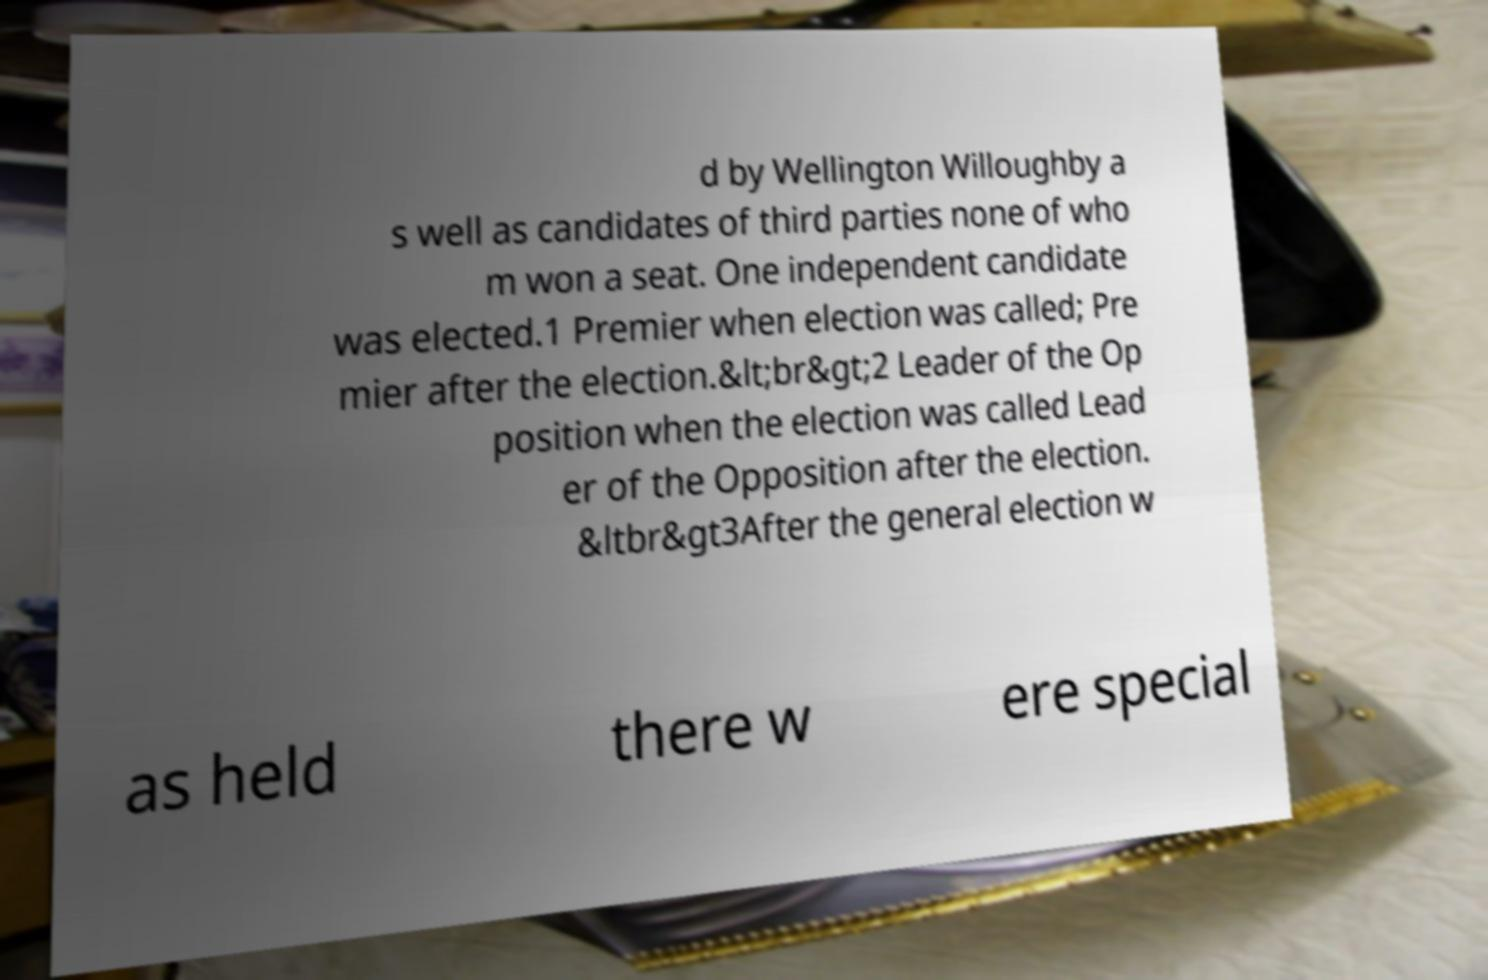Can you read and provide the text displayed in the image?This photo seems to have some interesting text. Can you extract and type it out for me? d by Wellington Willoughby a s well as candidates of third parties none of who m won a seat. One independent candidate was elected.1 Premier when election was called; Pre mier after the election.&lt;br&gt;2 Leader of the Op position when the election was called Lead er of the Opposition after the election. &ltbr&gt3After the general election w as held there w ere special 